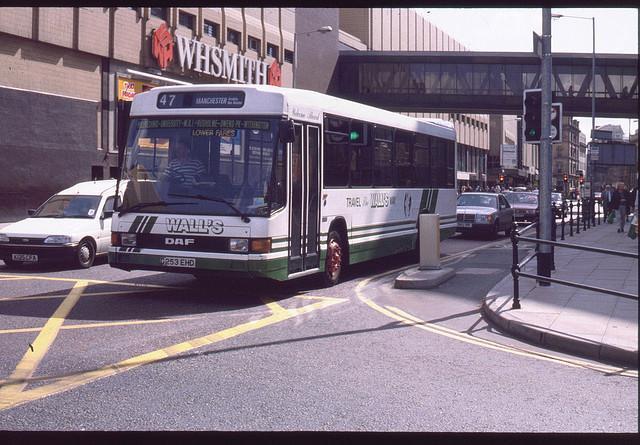How many cars are there?
Give a very brief answer. 2. 